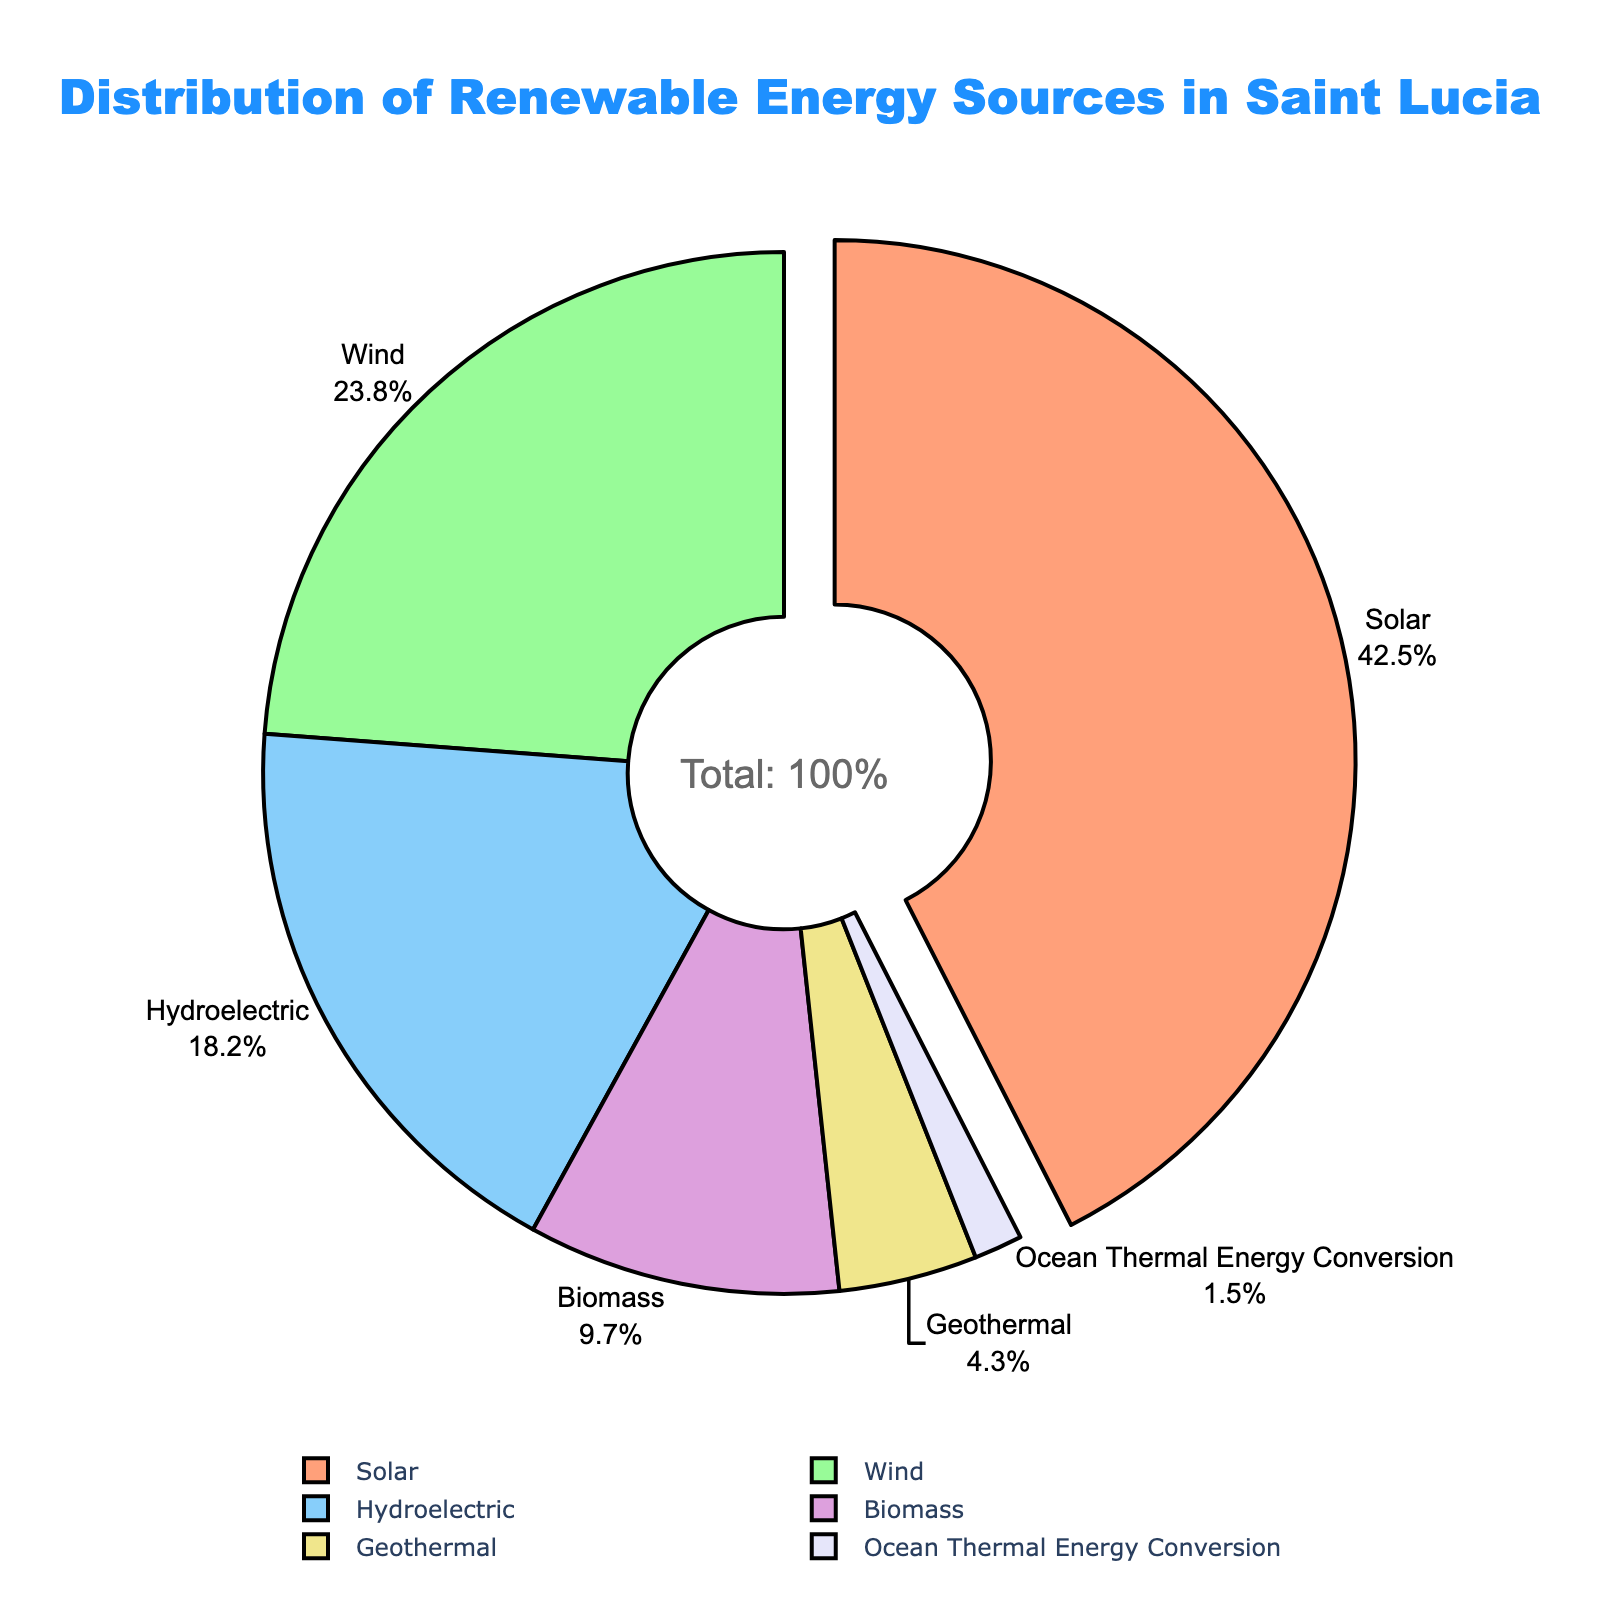Which renewable energy source has the highest share in Saint Lucia? The slice labeled "Solar" is the largest in the pie chart and is pulled away from the rest, indicating it has the highest share.
Answer: Solar What's the combined percentage of Wind and Hydroelectric energy sources? The Wind energy source has a percentage of 23.8% and the Hydroelectric has 18.2%. Adding these together: 23.8 + 18.2 = 42.0%.
Answer: 42.0% How does the share of Biomass compare to Geothermal energy? Biomass has a percentage of 9.7% and Geothermal has 4.3%. Since 9.7 is greater than 4.3, Biomass has a larger share than Geothermal energy.
Answer: Biomass has a larger share than Geothermal What is the color of the slice representing Ocean Thermal Energy Conversion? The Ocean Thermal Energy Conversion slice is colored in light lavender.
Answer: Light lavender Which energy source accounts for roughly a quarter of Saint Lucia's renewable energy distribution? The slice labeled "Wind" is 23.8%, which is close to a quarter (25%) of the energy distribution.
Answer: Wind What is the difference in percentage between Solar and Ocean Thermal Energy Conversion? Solar has 42.5% and Ocean Thermal Energy Conversion has 1.5%. Subtracting these: 42.5 - 1.5 = 41.0%.
Answer: 41.0% What proportion of the total energy is not from Solar or Wind sources? Solar has 42.5% and Wind has 23.8%. Adding these gives 66.3%. Subtracting from 100% (the complete circle): 100 - 66.3 = 33.7%.
Answer: 33.7% If the slices in the pie chart were combined into two groups, one with Biomass and Geothermal, and the other with all other sources, what would be the percentage for the Biomass and Geothermal group? Biomass has 9.7% and Geothermal has 4.3%. Adding these together: 9.7 + 4.3 = 14.0%.
Answer: 14.0% 